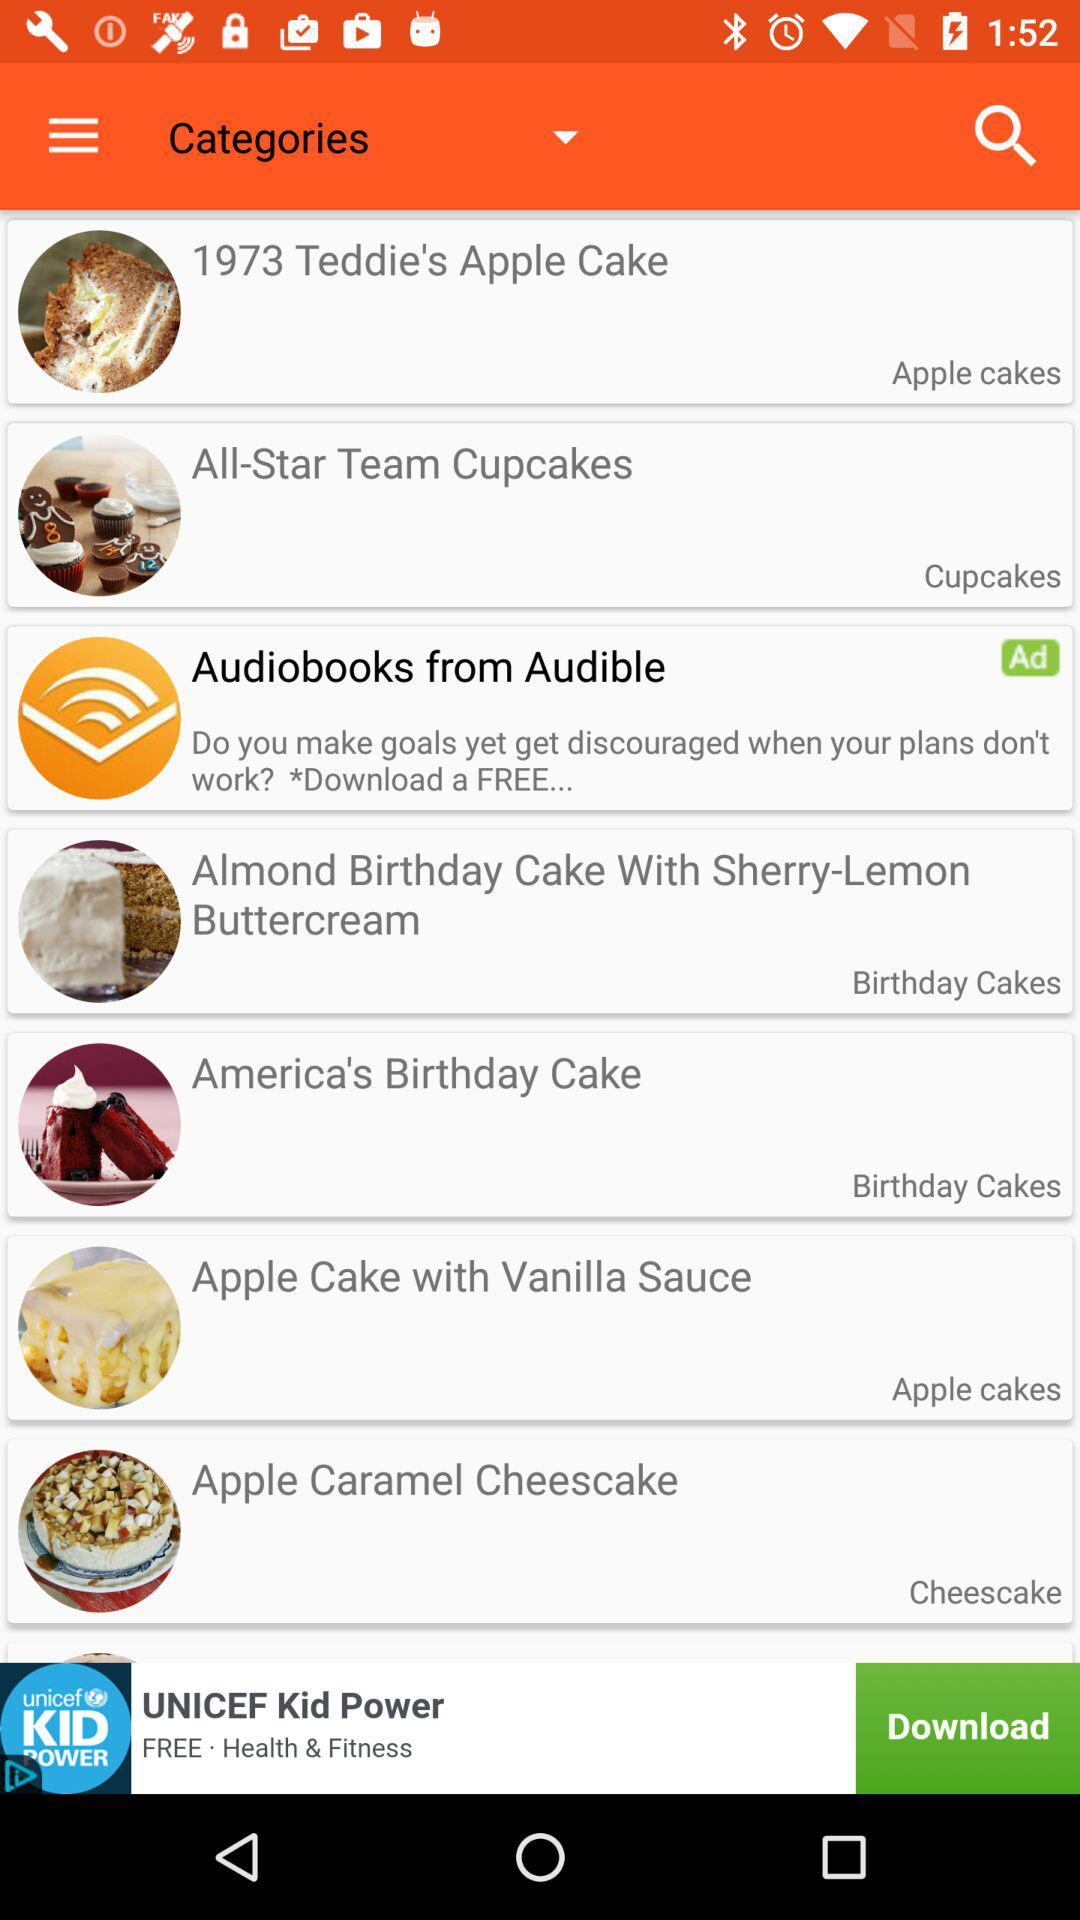Which store sells cheesecake?
When the provided information is insufficient, respond with <no answer>. <no answer> 